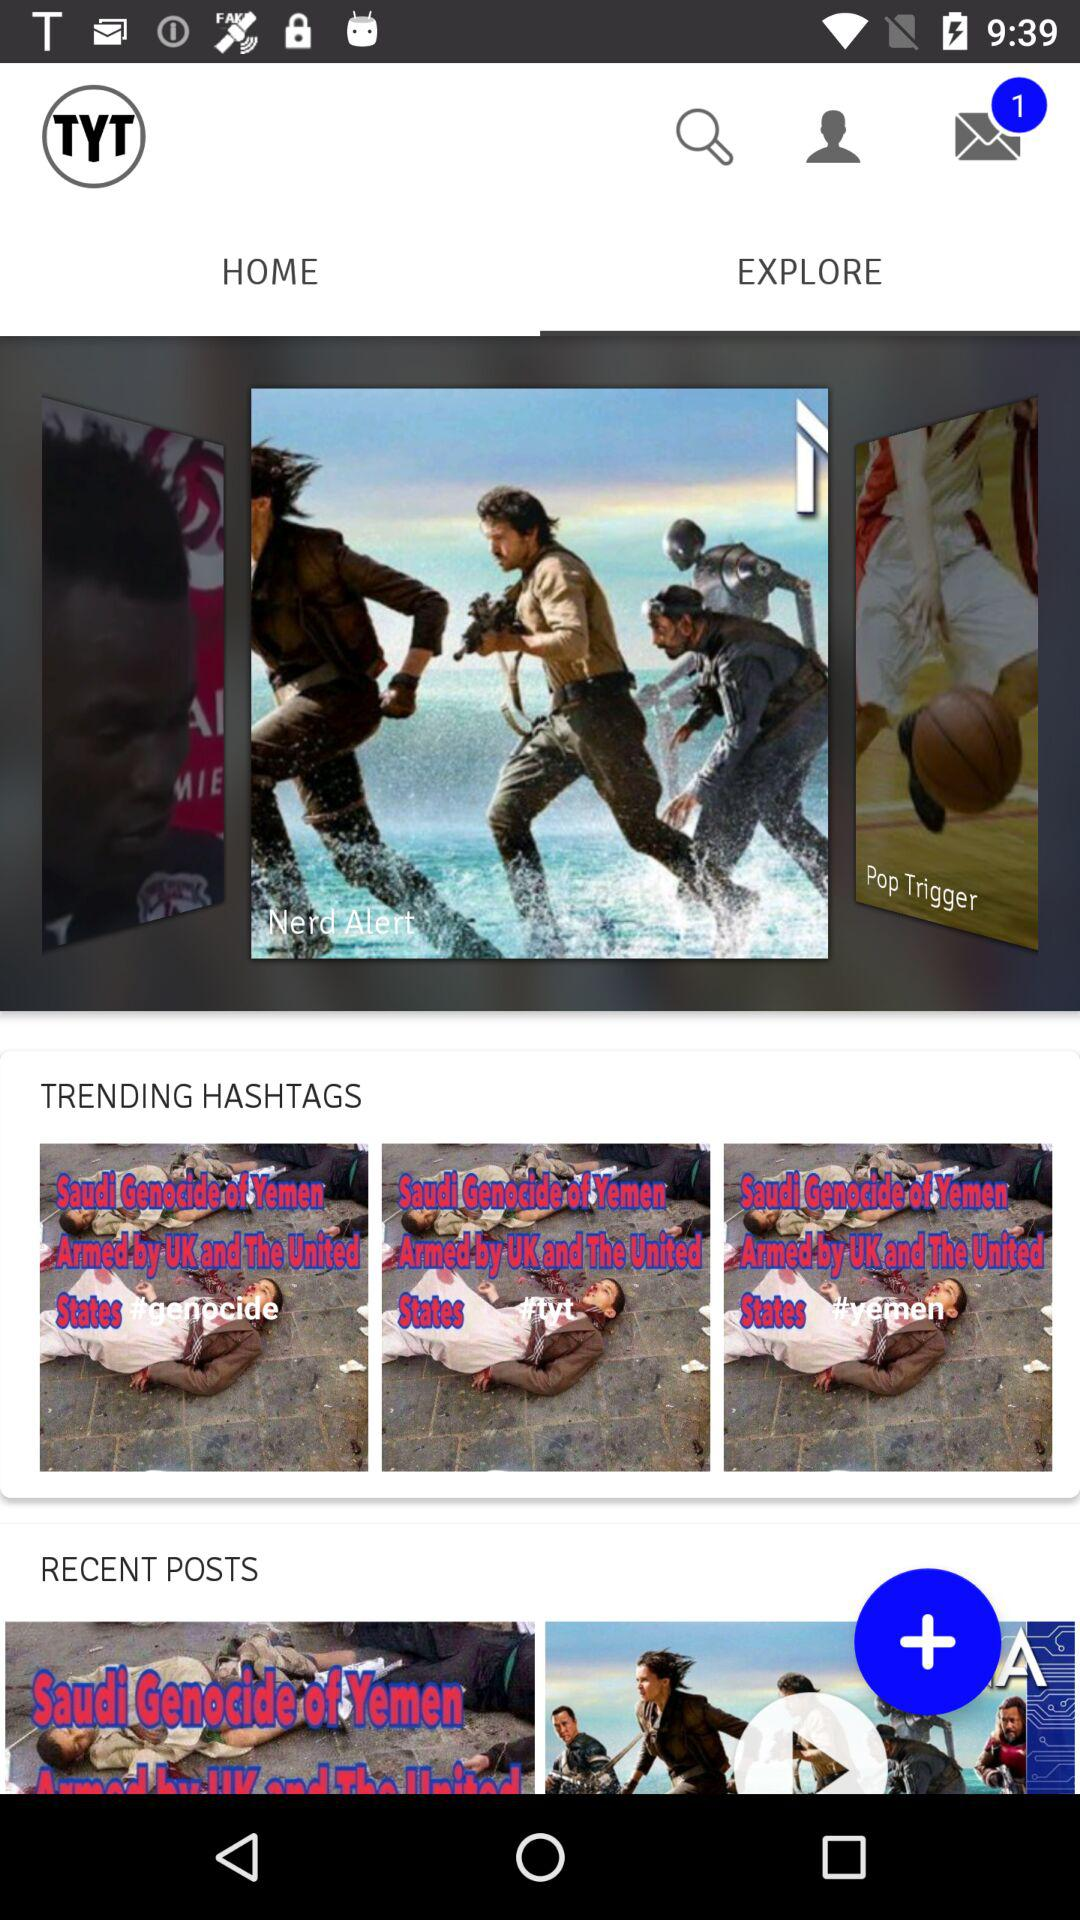Which tab is selected? The selected tab is "EXPLORE". 